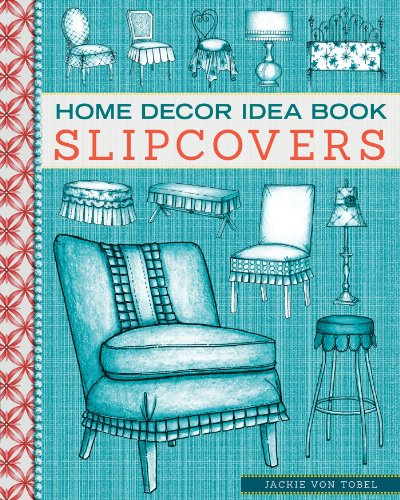What is the title of this book? The title of the book is 'Home Decor Idea Book: Upholstery, Slipcovers, and Seat Cushions,' a comprehensive resource for anyone interested in home furnishing and decoration. 